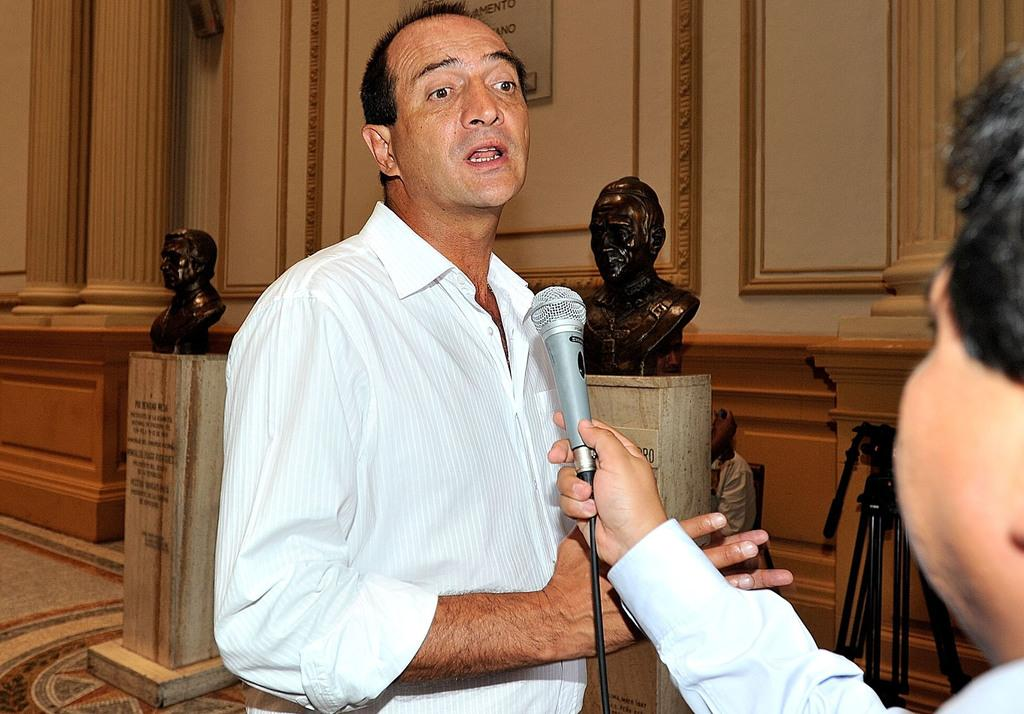What is the man in the image doing? There is a man speaking with a mic in front of him. Can you describe the other man in the image? There is another man holding a mic in front. What can be seen in the background of the image? There are two statues in the background. What type of juice is being served at the cart in the image? There is no cart or juice present in the image. How many team members are visible in the image? There is no team or team members mentioned in the image. 